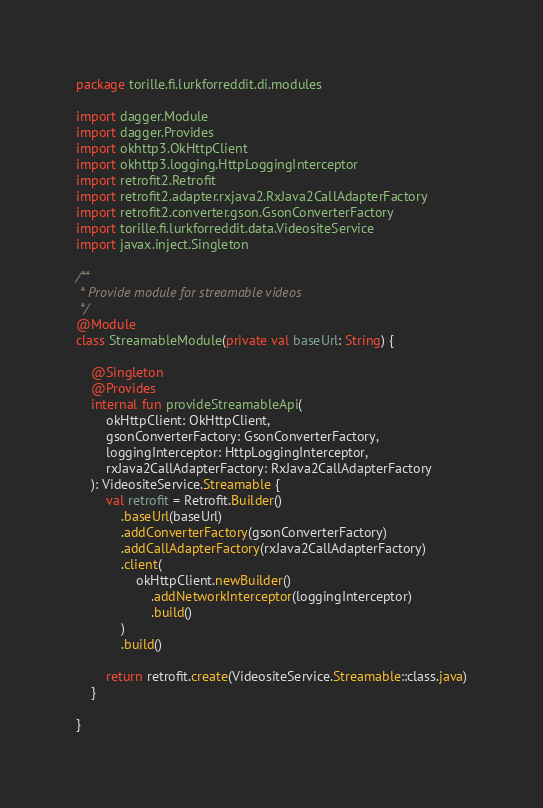<code> <loc_0><loc_0><loc_500><loc_500><_Kotlin_>package torille.fi.lurkforreddit.di.modules

import dagger.Module
import dagger.Provides
import okhttp3.OkHttpClient
import okhttp3.logging.HttpLoggingInterceptor
import retrofit2.Retrofit
import retrofit2.adapter.rxjava2.RxJava2CallAdapterFactory
import retrofit2.converter.gson.GsonConverterFactory
import torille.fi.lurkforreddit.data.VideositeService
import javax.inject.Singleton

/**
 * Provide module for streamable videos
 */
@Module
class StreamableModule(private val baseUrl: String) {

    @Singleton
    @Provides
    internal fun provideStreamableApi(
        okHttpClient: OkHttpClient,
        gsonConverterFactory: GsonConverterFactory,
        loggingInterceptor: HttpLoggingInterceptor,
        rxJava2CallAdapterFactory: RxJava2CallAdapterFactory
    ): VideositeService.Streamable {
        val retrofit = Retrofit.Builder()
            .baseUrl(baseUrl)
            .addConverterFactory(gsonConverterFactory)
            .addCallAdapterFactory(rxJava2CallAdapterFactory)
            .client(
                okHttpClient.newBuilder()
                    .addNetworkInterceptor(loggingInterceptor)
                    .build()
            )
            .build()

        return retrofit.create(VideositeService.Streamable::class.java)
    }

}
</code> 